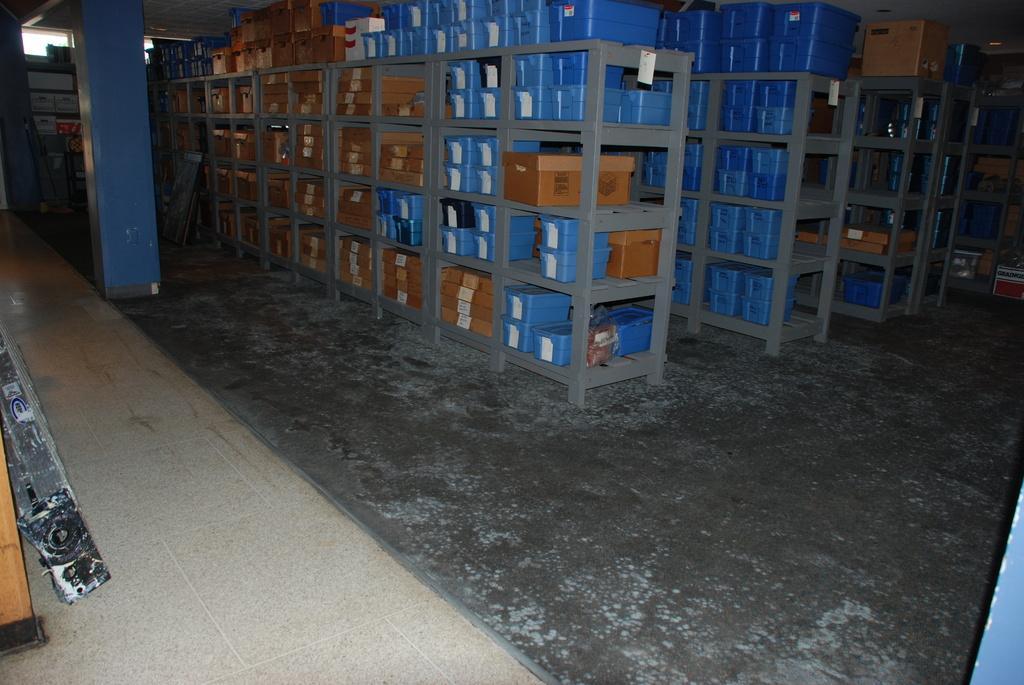Describe this image in one or two sentences. In this image, we can see some racks contains boxes. There is a pillar in the top left of the image. 